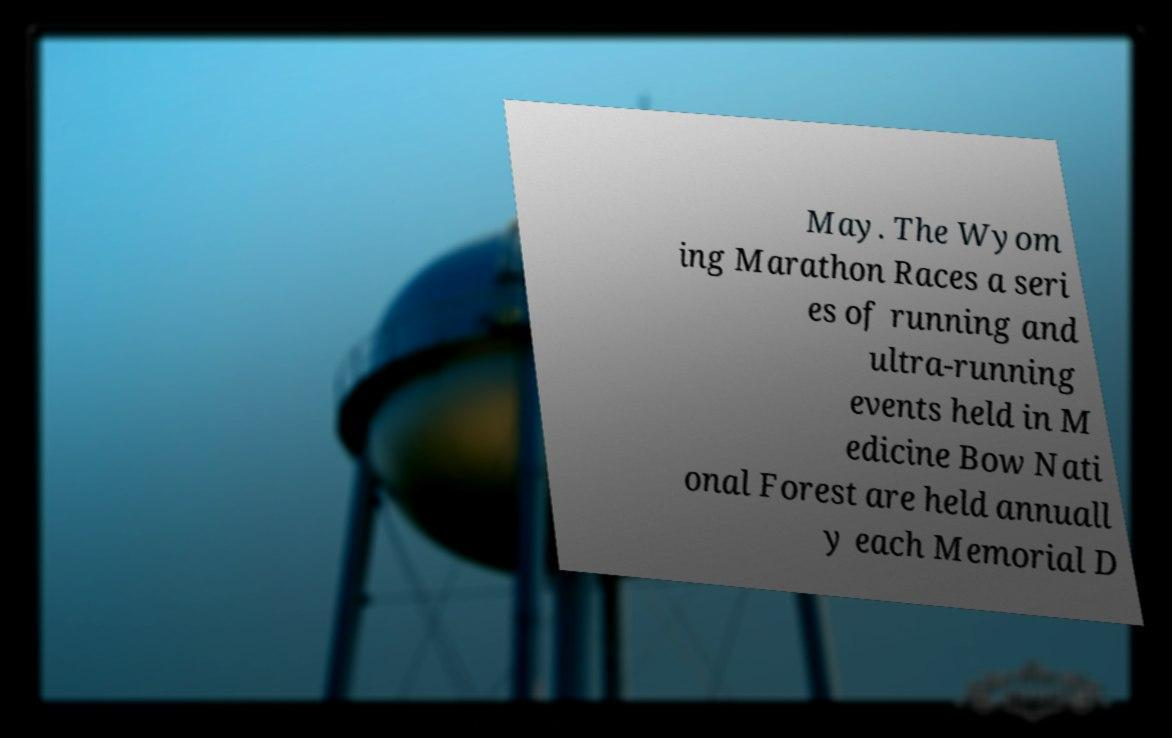Could you assist in decoding the text presented in this image and type it out clearly? May. The Wyom ing Marathon Races a seri es of running and ultra-running events held in M edicine Bow Nati onal Forest are held annuall y each Memorial D 